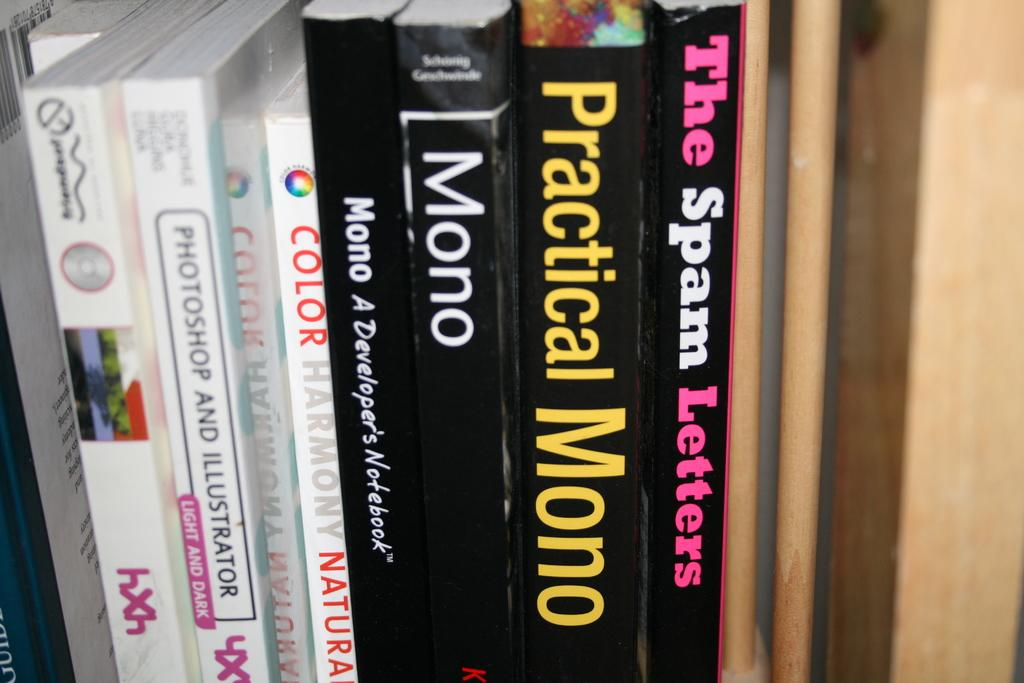Provide a one-sentence caption for the provided image. Various books on a bookshelf about programming mono and Photoshop. 